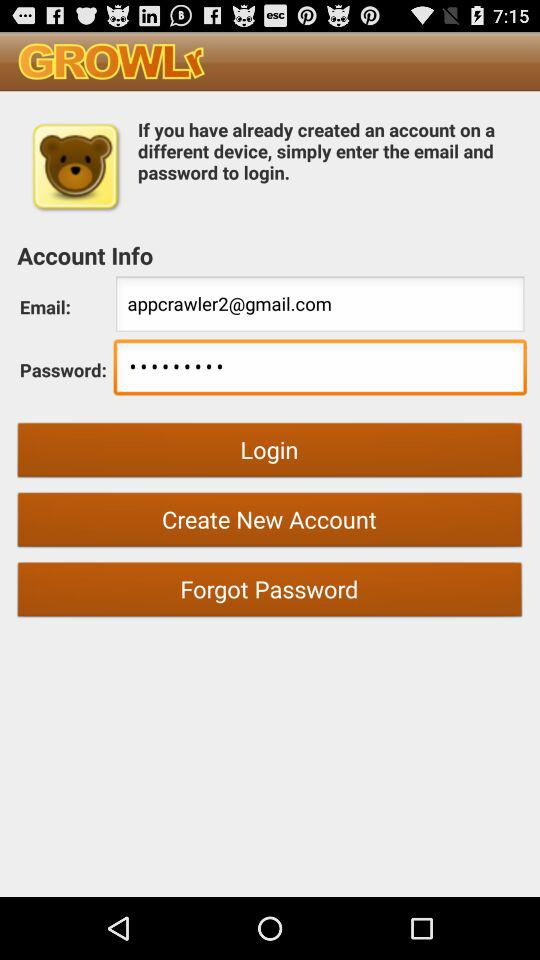What is the email address? The email address is appcrawler2@gmail.com. 